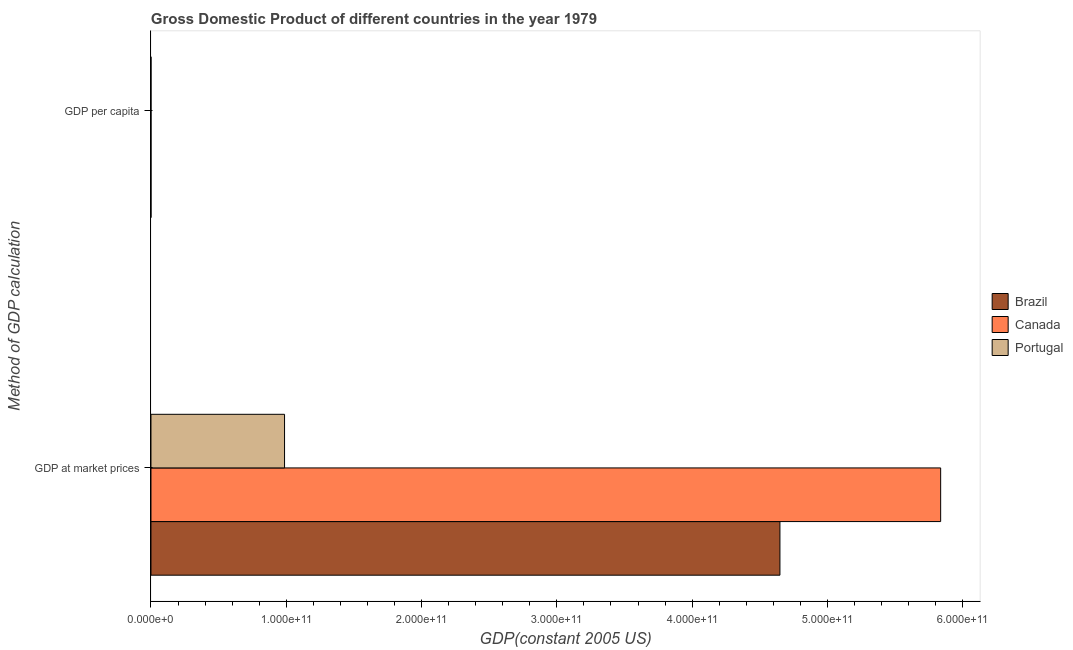How many different coloured bars are there?
Provide a short and direct response. 3. Are the number of bars per tick equal to the number of legend labels?
Provide a short and direct response. Yes. How many bars are there on the 2nd tick from the top?
Keep it short and to the point. 3. How many bars are there on the 1st tick from the bottom?
Ensure brevity in your answer.  3. What is the label of the 2nd group of bars from the top?
Your answer should be very brief. GDP at market prices. What is the gdp per capita in Brazil?
Your answer should be very brief. 3895.66. Across all countries, what is the maximum gdp per capita?
Provide a succinct answer. 2.40e+04. Across all countries, what is the minimum gdp at market prices?
Your answer should be very brief. 9.87e+1. In which country was the gdp at market prices minimum?
Provide a succinct answer. Portugal. What is the total gdp at market prices in the graph?
Give a very brief answer. 1.15e+12. What is the difference between the gdp at market prices in Canada and that in Portugal?
Keep it short and to the point. 4.85e+11. What is the difference between the gdp per capita in Portugal and the gdp at market prices in Canada?
Keep it short and to the point. -5.84e+11. What is the average gdp at market prices per country?
Your answer should be very brief. 3.82e+11. What is the difference between the gdp per capita and gdp at market prices in Portugal?
Offer a very short reply. -9.87e+1. What is the ratio of the gdp per capita in Canada to that in Portugal?
Give a very brief answer. 2.35. What does the 3rd bar from the top in GDP at market prices represents?
Keep it short and to the point. Brazil. What does the 3rd bar from the bottom in GDP at market prices represents?
Provide a succinct answer. Portugal. How many bars are there?
Provide a short and direct response. 6. What is the difference between two consecutive major ticks on the X-axis?
Make the answer very short. 1.00e+11. Does the graph contain any zero values?
Offer a terse response. No. How are the legend labels stacked?
Offer a terse response. Vertical. What is the title of the graph?
Offer a terse response. Gross Domestic Product of different countries in the year 1979. What is the label or title of the X-axis?
Your answer should be compact. GDP(constant 2005 US). What is the label or title of the Y-axis?
Ensure brevity in your answer.  Method of GDP calculation. What is the GDP(constant 2005 US) in Brazil in GDP at market prices?
Provide a succinct answer. 4.65e+11. What is the GDP(constant 2005 US) of Canada in GDP at market prices?
Provide a short and direct response. 5.84e+11. What is the GDP(constant 2005 US) of Portugal in GDP at market prices?
Keep it short and to the point. 9.87e+1. What is the GDP(constant 2005 US) of Brazil in GDP per capita?
Provide a succinct answer. 3895.66. What is the GDP(constant 2005 US) of Canada in GDP per capita?
Your answer should be compact. 2.40e+04. What is the GDP(constant 2005 US) of Portugal in GDP per capita?
Make the answer very short. 1.02e+04. Across all Method of GDP calculation, what is the maximum GDP(constant 2005 US) of Brazil?
Provide a short and direct response. 4.65e+11. Across all Method of GDP calculation, what is the maximum GDP(constant 2005 US) of Canada?
Your response must be concise. 5.84e+11. Across all Method of GDP calculation, what is the maximum GDP(constant 2005 US) of Portugal?
Provide a short and direct response. 9.87e+1. Across all Method of GDP calculation, what is the minimum GDP(constant 2005 US) in Brazil?
Your answer should be very brief. 3895.66. Across all Method of GDP calculation, what is the minimum GDP(constant 2005 US) of Canada?
Offer a very short reply. 2.40e+04. Across all Method of GDP calculation, what is the minimum GDP(constant 2005 US) of Portugal?
Your response must be concise. 1.02e+04. What is the total GDP(constant 2005 US) in Brazil in the graph?
Your response must be concise. 4.65e+11. What is the total GDP(constant 2005 US) of Canada in the graph?
Give a very brief answer. 5.84e+11. What is the total GDP(constant 2005 US) of Portugal in the graph?
Provide a succinct answer. 9.87e+1. What is the difference between the GDP(constant 2005 US) of Brazil in GDP at market prices and that in GDP per capita?
Your answer should be compact. 4.65e+11. What is the difference between the GDP(constant 2005 US) in Canada in GDP at market prices and that in GDP per capita?
Your answer should be compact. 5.84e+11. What is the difference between the GDP(constant 2005 US) in Portugal in GDP at market prices and that in GDP per capita?
Your answer should be very brief. 9.87e+1. What is the difference between the GDP(constant 2005 US) in Brazil in GDP at market prices and the GDP(constant 2005 US) in Canada in GDP per capita?
Keep it short and to the point. 4.65e+11. What is the difference between the GDP(constant 2005 US) of Brazil in GDP at market prices and the GDP(constant 2005 US) of Portugal in GDP per capita?
Your answer should be compact. 4.65e+11. What is the difference between the GDP(constant 2005 US) of Canada in GDP at market prices and the GDP(constant 2005 US) of Portugal in GDP per capita?
Your answer should be compact. 5.84e+11. What is the average GDP(constant 2005 US) of Brazil per Method of GDP calculation?
Your answer should be compact. 2.32e+11. What is the average GDP(constant 2005 US) in Canada per Method of GDP calculation?
Your answer should be compact. 2.92e+11. What is the average GDP(constant 2005 US) in Portugal per Method of GDP calculation?
Your response must be concise. 4.94e+1. What is the difference between the GDP(constant 2005 US) in Brazil and GDP(constant 2005 US) in Canada in GDP at market prices?
Keep it short and to the point. -1.19e+11. What is the difference between the GDP(constant 2005 US) of Brazil and GDP(constant 2005 US) of Portugal in GDP at market prices?
Offer a terse response. 3.66e+11. What is the difference between the GDP(constant 2005 US) in Canada and GDP(constant 2005 US) in Portugal in GDP at market prices?
Ensure brevity in your answer.  4.85e+11. What is the difference between the GDP(constant 2005 US) of Brazil and GDP(constant 2005 US) of Canada in GDP per capita?
Offer a very short reply. -2.01e+04. What is the difference between the GDP(constant 2005 US) of Brazil and GDP(constant 2005 US) of Portugal in GDP per capita?
Your answer should be very brief. -6324.65. What is the difference between the GDP(constant 2005 US) of Canada and GDP(constant 2005 US) of Portugal in GDP per capita?
Offer a terse response. 1.38e+04. What is the ratio of the GDP(constant 2005 US) in Brazil in GDP at market prices to that in GDP per capita?
Give a very brief answer. 1.19e+08. What is the ratio of the GDP(constant 2005 US) of Canada in GDP at market prices to that in GDP per capita?
Provide a succinct answer. 2.43e+07. What is the ratio of the GDP(constant 2005 US) in Portugal in GDP at market prices to that in GDP per capita?
Your answer should be compact. 9.66e+06. What is the difference between the highest and the second highest GDP(constant 2005 US) in Brazil?
Ensure brevity in your answer.  4.65e+11. What is the difference between the highest and the second highest GDP(constant 2005 US) in Canada?
Make the answer very short. 5.84e+11. What is the difference between the highest and the second highest GDP(constant 2005 US) of Portugal?
Offer a terse response. 9.87e+1. What is the difference between the highest and the lowest GDP(constant 2005 US) of Brazil?
Provide a succinct answer. 4.65e+11. What is the difference between the highest and the lowest GDP(constant 2005 US) of Canada?
Give a very brief answer. 5.84e+11. What is the difference between the highest and the lowest GDP(constant 2005 US) of Portugal?
Give a very brief answer. 9.87e+1. 